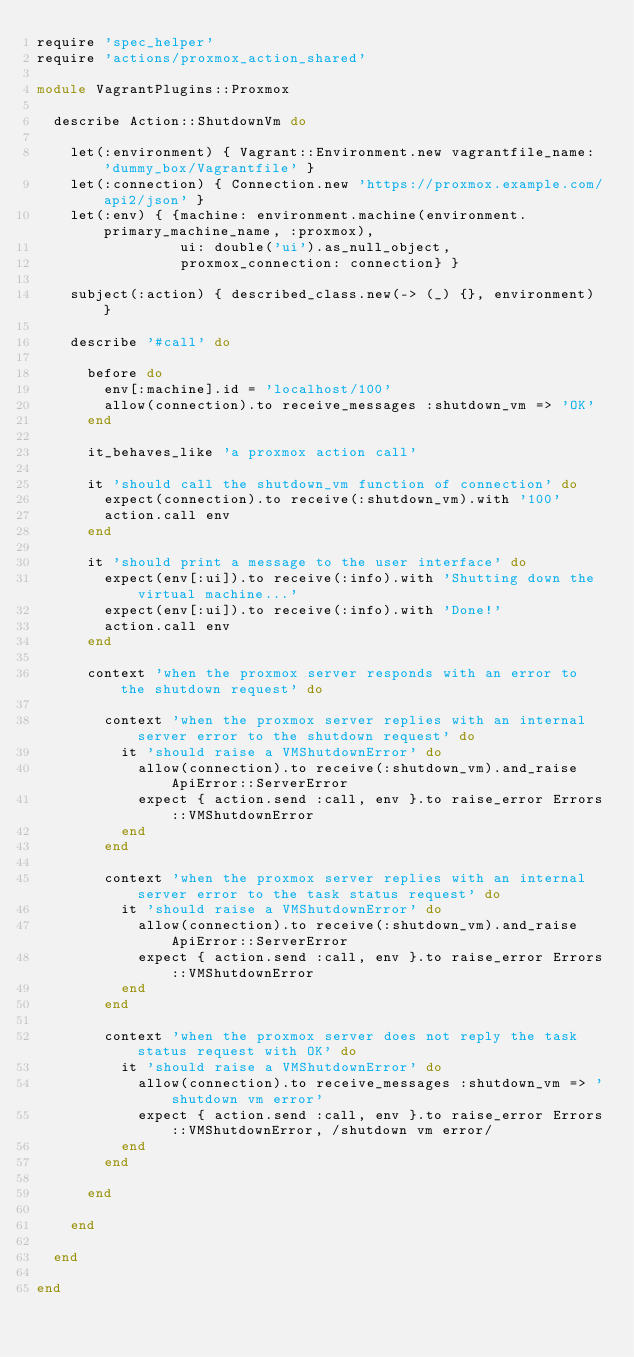Convert code to text. <code><loc_0><loc_0><loc_500><loc_500><_Ruby_>require 'spec_helper'
require 'actions/proxmox_action_shared'

module VagrantPlugins::Proxmox

	describe Action::ShutdownVm do

		let(:environment) { Vagrant::Environment.new vagrantfile_name: 'dummy_box/Vagrantfile' }
		let(:connection) { Connection.new 'https://proxmox.example.com/api2/json' }
		let(:env) { {machine: environment.machine(environment.primary_machine_name, :proxmox),
								 ui: double('ui').as_null_object,
								 proxmox_connection: connection} }

		subject(:action) { described_class.new(-> (_) {}, environment) }

		describe '#call' do

			before do
				env[:machine].id = 'localhost/100'
				allow(connection).to receive_messages :shutdown_vm => 'OK'
			end

			it_behaves_like 'a proxmox action call'

			it 'should call the shutdown_vm function of connection' do
				expect(connection).to receive(:shutdown_vm).with '100'
				action.call env
			end

			it 'should print a message to the user interface' do
				expect(env[:ui]).to receive(:info).with 'Shutting down the virtual machine...'
				expect(env[:ui]).to receive(:info).with 'Done!'
				action.call env
			end

			context 'when the proxmox server responds with an error to the shutdown request' do

				context 'when the proxmox server replies with an internal server error to the shutdown request' do
					it 'should raise a VMShutdownError' do
						allow(connection).to receive(:shutdown_vm).and_raise ApiError::ServerError
						expect { action.send :call, env }.to raise_error Errors::VMShutdownError
					end
				end

				context 'when the proxmox server replies with an internal server error to the task status request' do
					it 'should raise a VMShutdownError' do
						allow(connection).to receive(:shutdown_vm).and_raise ApiError::ServerError
						expect { action.send :call, env }.to raise_error Errors::VMShutdownError
					end
				end

				context 'when the proxmox server does not reply the task status request with OK' do
					it 'should raise a VMShutdownError' do
						allow(connection).to receive_messages :shutdown_vm => 'shutdown vm error'
						expect { action.send :call, env }.to raise_error Errors::VMShutdownError, /shutdown vm error/
					end
				end

			end

		end

	end

end
</code> 